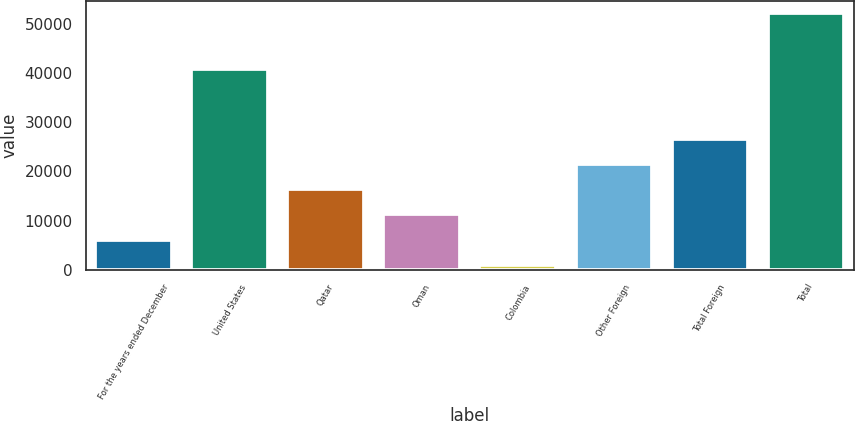Convert chart. <chart><loc_0><loc_0><loc_500><loc_500><bar_chart><fcel>For the years ended December<fcel>United States<fcel>Qatar<fcel>Oman<fcel>Colombia<fcel>Other Foreign<fcel>Total Foreign<fcel>Total<nl><fcel>6143.3<fcel>40786<fcel>16347.9<fcel>11245.6<fcel>1041<fcel>21450.2<fcel>26552.5<fcel>52064<nl></chart> 